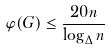<formula> <loc_0><loc_0><loc_500><loc_500>\varphi ( G ) \leq \frac { 2 0 n } { \log _ { \Delta } n }</formula> 